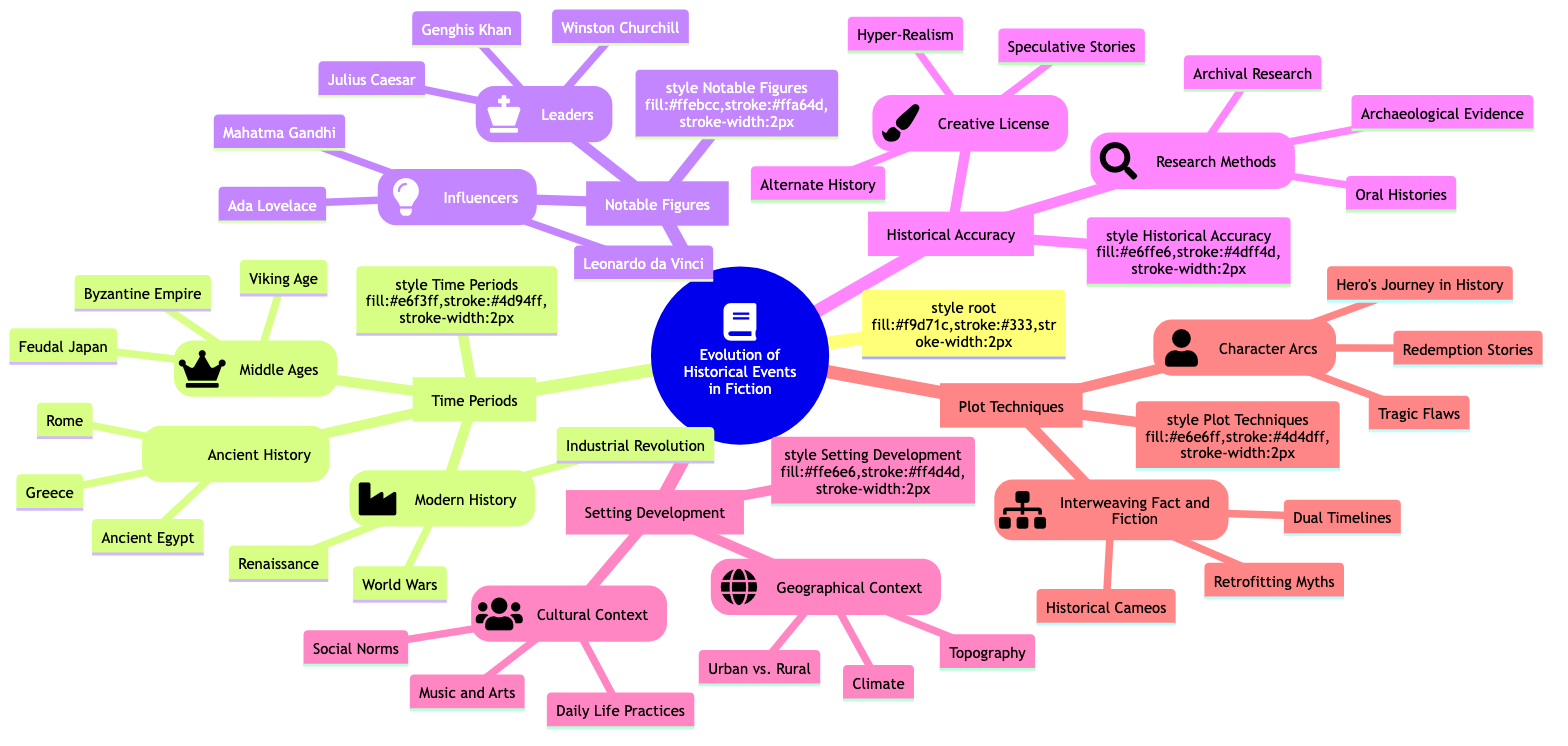What are the three time periods listed? The diagram shows three main time periods under the "Time Periods" node: Ancient History, Middle Ages, and Modern History. Each of these represents a distinct era in historical events depicted in fiction.
Answer: Ancient History, Middle Ages, Modern History Name one example from the Middle Ages. In the "Middle Ages" subtopic, "Byzantine Empire," "Viking Age," and "Feudal Japan" are listed as examples. Selecting just one of these fulfills the question requirement.
Answer: Byzantine Empire How many notable figures are mentioned in total? Under the "Notable Figures" node, there are two subnodes: "Leaders" and "Influencers," each with three examples. Therefore, the total number of notable figures is the sum of the counts in each subnode: 3 (Leaders) + 3 (Influencers) = 6.
Answer: 6 What type of research method is categorized under Historical Accuracy? The "Historical Accuracy" section lists various research methods, one of which is "Archival Research." This identifies the type of research that focuses on examining historical records.
Answer: Archival Research Which character arc technique is associated with historical narratives? The "Character Arcs" subnode under "Plot Techniques" provides various examples, one of which is "Hero's Journey in History," which specifically ties to narratives in historical fiction.
Answer: Hero's Journey in History What distinguishes Creative License within Historical Accuracy? "Creative License," as shown in the "Historical Accuracy" section, includes various storytelling approaches like "Alternate History," allowing authors to diverge from strict historical accuracy. This technique emphasizes the flexibility in crafting narratives.
Answer: Alternate History What example falls under Geographical Context? The "Geographical Context" subtopic provides examples like "Topography," which illustrates how the physical characteristics of a landscape influence the setting in historical fiction narratives.
Answer: Topography How are time periods related to plot techniques? The diagram shows that both "Time Periods" and "Plot Techniques" are subtopics of the main topic, implying their connection. Different time periods influence the methods and stories authors choose to explore within the framework of plot techniques.
Answer: Influence each other What is a unique aspect of the Setting Development category? The "Setting Development" category is divided into "Geographical Context" and "Cultural Context," demonstrating its comprehensive approach to depicting the various elements that shape historical fiction settings.
Answer: Geographical and Cultural Contexts 